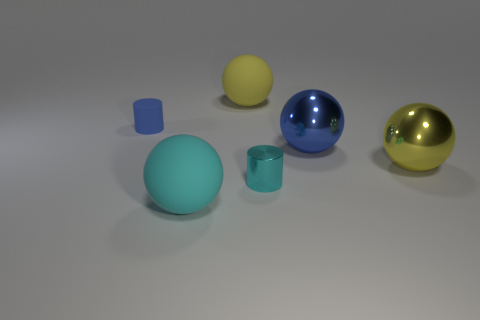There is a object that is in front of the small metallic thing; is it the same color as the tiny thing that is on the right side of the big yellow matte ball?
Your answer should be very brief. Yes. There is a metallic thing that is the same color as the small matte object; what shape is it?
Offer a terse response. Sphere. Is there a purple cylinder that has the same size as the cyan cylinder?
Your response must be concise. No. How many tiny cyan cylinders are to the left of the object that is in front of the small metallic cylinder?
Provide a succinct answer. 0. What material is the large cyan sphere?
Offer a terse response. Rubber. There is a big blue metal object; what number of cylinders are in front of it?
Your response must be concise. 1. Do the metallic cylinder and the small rubber object have the same color?
Keep it short and to the point. No. How many other tiny matte cylinders have the same color as the rubber cylinder?
Give a very brief answer. 0. Is the number of shiny cylinders greater than the number of purple shiny cubes?
Your response must be concise. Yes. There is a rubber object that is behind the big yellow metallic object and in front of the big yellow matte ball; how big is it?
Ensure brevity in your answer.  Small. 